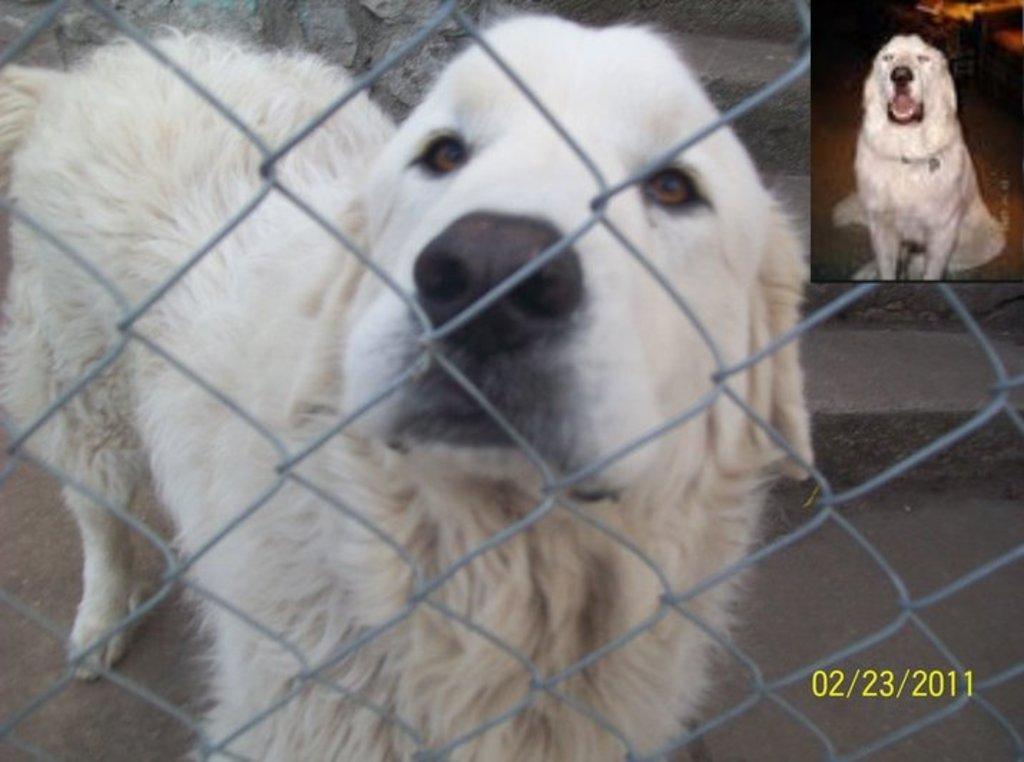Describe this image in one or two sentences. In this picture there is a white color dog sitting and looking into the camera. On the right top side there is a another white color dog sitting and backing. On the bottom right side there is a date mentioned in the image. 